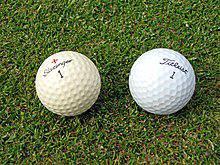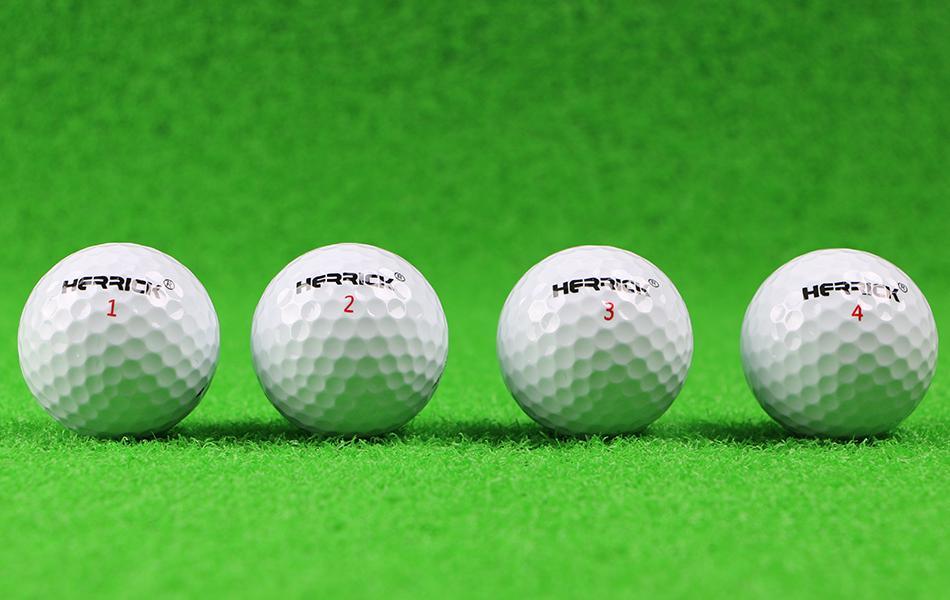The first image is the image on the left, the second image is the image on the right. Assess this claim about the two images: "There are exactly two golf balls in one of the images.". Correct or not? Answer yes or no. Yes. The first image is the image on the left, the second image is the image on the right. For the images shown, is this caption "One image contains a mass of all-white balls on green turf, most with no space between them." true? Answer yes or no. No. 